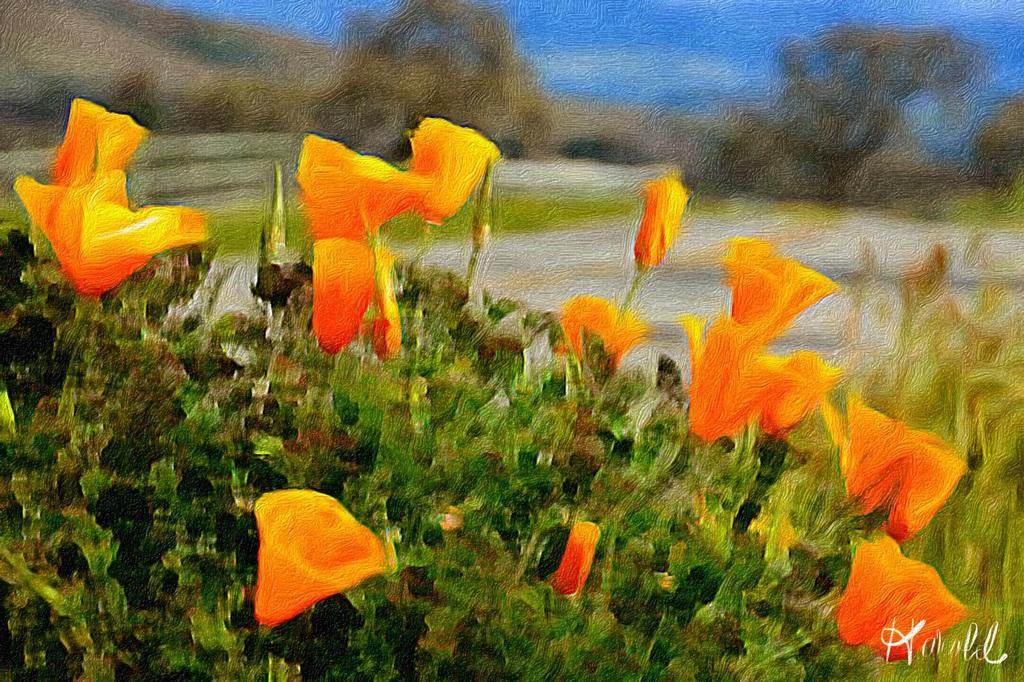What type of living organisms can be seen in the image? There are flowers in the image. What are the flowers attached to? The flowers are on plants. What colors are the flowers? The flowers are in yellow and orange colors. What can be seen in the background of the image? The background of the image includes the ground and the sky. How would you describe the sky in the image? The sky is visible in the background of the image, and it appears to be blue and blurry. What type of organization is responsible for the ticket distribution in the image? There is no mention of tickets or an organization in the image; it features flowers on plants with a blue and blurry sky in the background. 